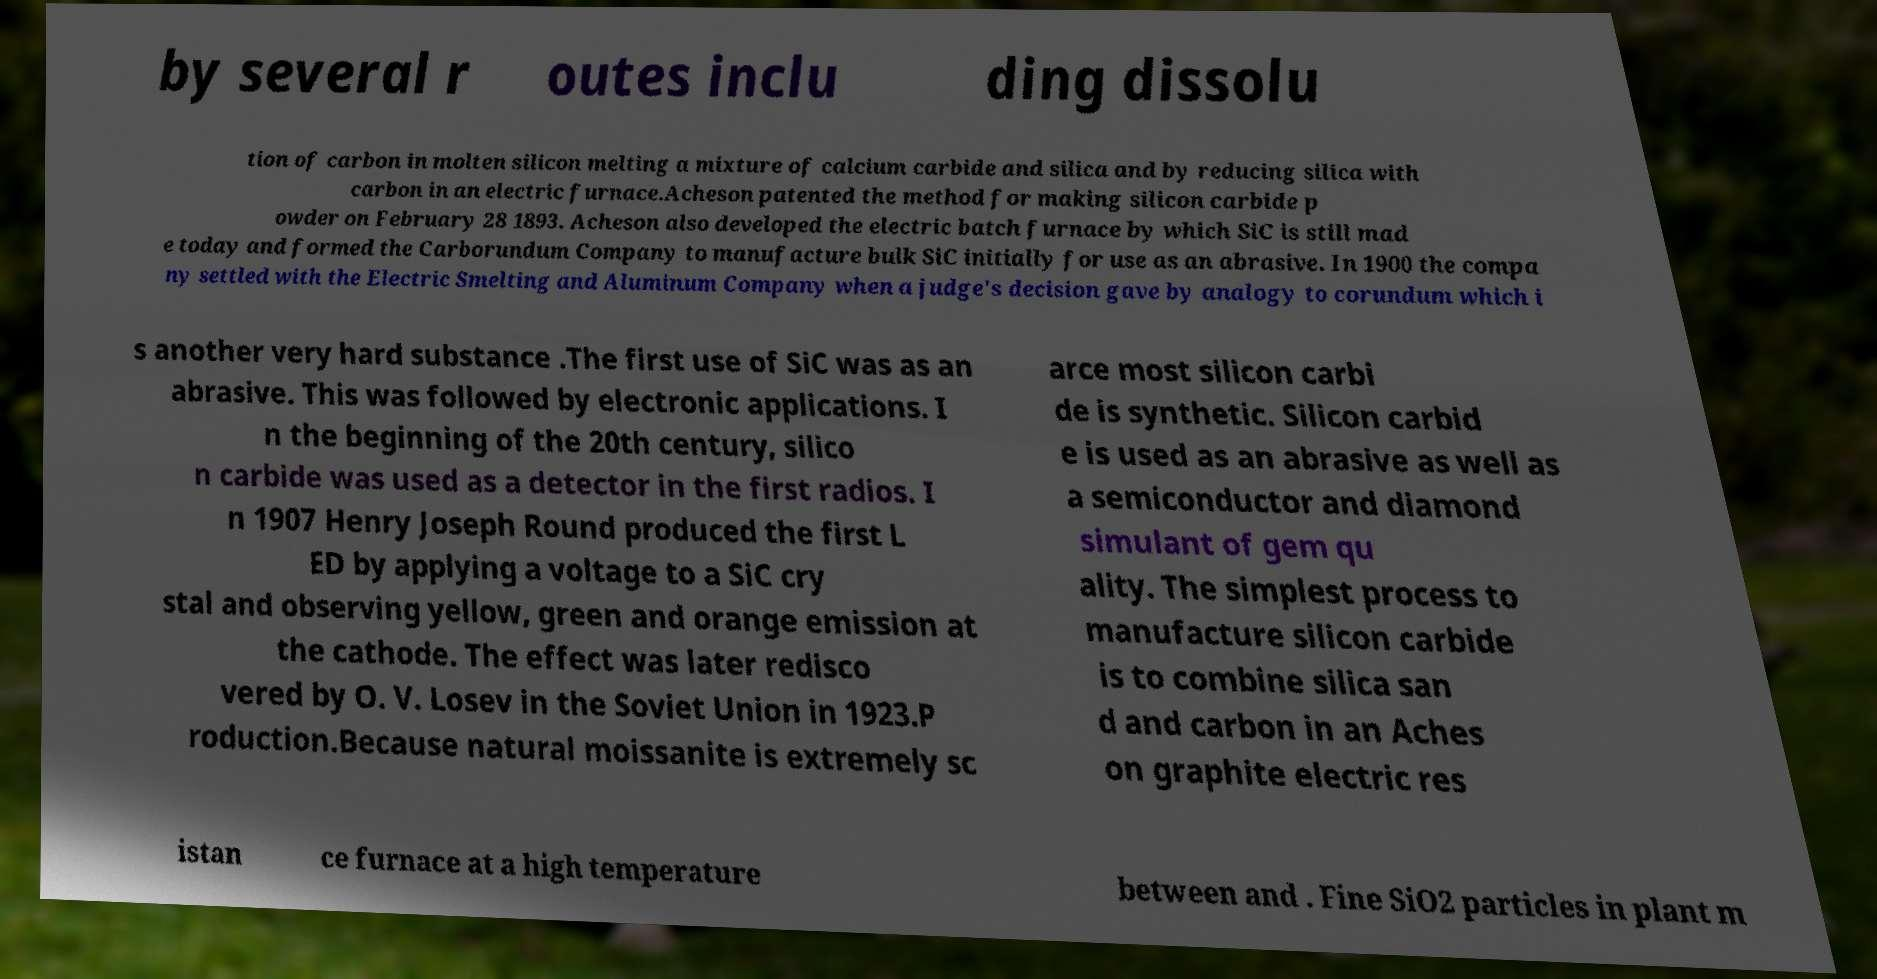What messages or text are displayed in this image? I need them in a readable, typed format. by several r outes inclu ding dissolu tion of carbon in molten silicon melting a mixture of calcium carbide and silica and by reducing silica with carbon in an electric furnace.Acheson patented the method for making silicon carbide p owder on February 28 1893. Acheson also developed the electric batch furnace by which SiC is still mad e today and formed the Carborundum Company to manufacture bulk SiC initially for use as an abrasive. In 1900 the compa ny settled with the Electric Smelting and Aluminum Company when a judge's decision gave by analogy to corundum which i s another very hard substance .The first use of SiC was as an abrasive. This was followed by electronic applications. I n the beginning of the 20th century, silico n carbide was used as a detector in the first radios. I n 1907 Henry Joseph Round produced the first L ED by applying a voltage to a SiC cry stal and observing yellow, green and orange emission at the cathode. The effect was later redisco vered by O. V. Losev in the Soviet Union in 1923.P roduction.Because natural moissanite is extremely sc arce most silicon carbi de is synthetic. Silicon carbid e is used as an abrasive as well as a semiconductor and diamond simulant of gem qu ality. The simplest process to manufacture silicon carbide is to combine silica san d and carbon in an Aches on graphite electric res istan ce furnace at a high temperature between and . Fine SiO2 particles in plant m 